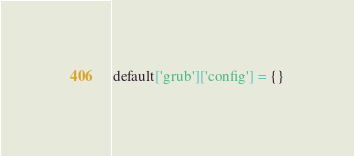Convert code to text. <code><loc_0><loc_0><loc_500><loc_500><_Ruby_>default['grub']['config'] = {}
</code> 